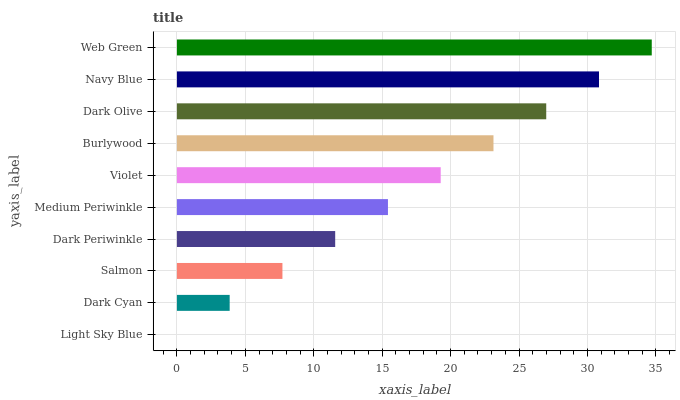Is Light Sky Blue the minimum?
Answer yes or no. Yes. Is Web Green the maximum?
Answer yes or no. Yes. Is Dark Cyan the minimum?
Answer yes or no. No. Is Dark Cyan the maximum?
Answer yes or no. No. Is Dark Cyan greater than Light Sky Blue?
Answer yes or no. Yes. Is Light Sky Blue less than Dark Cyan?
Answer yes or no. Yes. Is Light Sky Blue greater than Dark Cyan?
Answer yes or no. No. Is Dark Cyan less than Light Sky Blue?
Answer yes or no. No. Is Violet the high median?
Answer yes or no. Yes. Is Medium Periwinkle the low median?
Answer yes or no. Yes. Is Navy Blue the high median?
Answer yes or no. No. Is Dark Olive the low median?
Answer yes or no. No. 